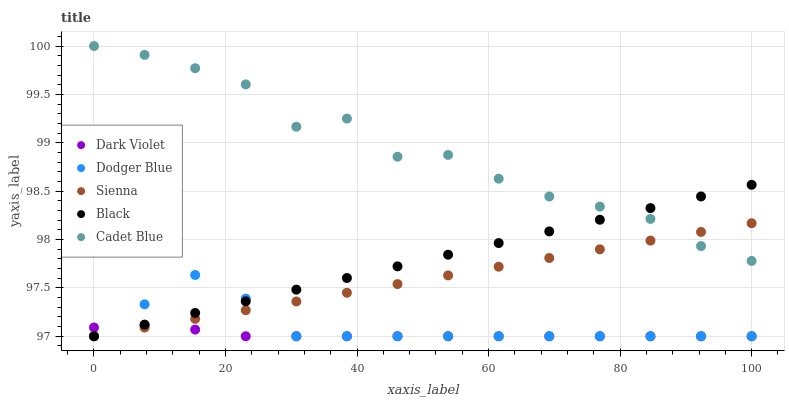Does Dark Violet have the minimum area under the curve?
Answer yes or no. Yes. Does Cadet Blue have the maximum area under the curve?
Answer yes or no. Yes. Does Black have the minimum area under the curve?
Answer yes or no. No. Does Black have the maximum area under the curve?
Answer yes or no. No. Is Black the smoothest?
Answer yes or no. Yes. Is Cadet Blue the roughest?
Answer yes or no. Yes. Is Cadet Blue the smoothest?
Answer yes or no. No. Is Black the roughest?
Answer yes or no. No. Does Sienna have the lowest value?
Answer yes or no. Yes. Does Cadet Blue have the lowest value?
Answer yes or no. No. Does Cadet Blue have the highest value?
Answer yes or no. Yes. Does Black have the highest value?
Answer yes or no. No. Is Dodger Blue less than Cadet Blue?
Answer yes or no. Yes. Is Cadet Blue greater than Dark Violet?
Answer yes or no. Yes. Does Dark Violet intersect Dodger Blue?
Answer yes or no. Yes. Is Dark Violet less than Dodger Blue?
Answer yes or no. No. Is Dark Violet greater than Dodger Blue?
Answer yes or no. No. Does Dodger Blue intersect Cadet Blue?
Answer yes or no. No. 